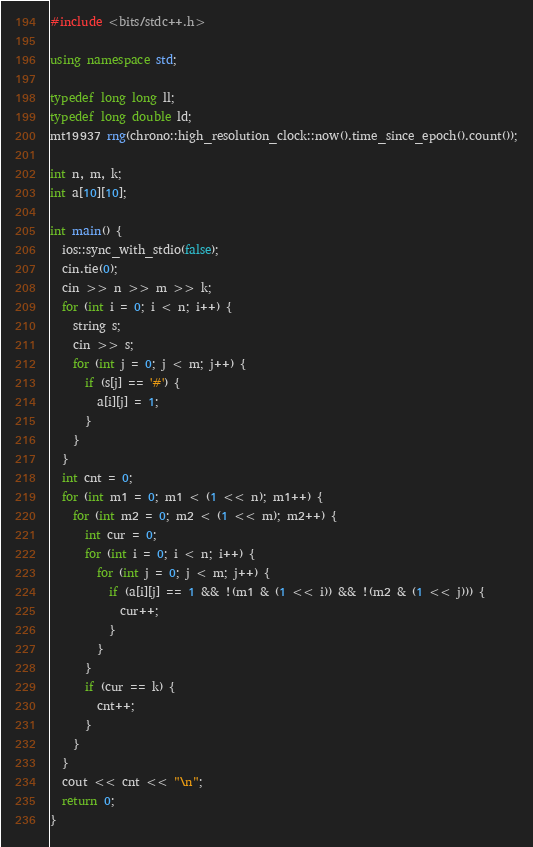<code> <loc_0><loc_0><loc_500><loc_500><_C++_>#include <bits/stdc++.h>

using namespace std;

typedef long long ll;
typedef long double ld;
mt19937 rng(chrono::high_resolution_clock::now().time_since_epoch().count());

int n, m, k;
int a[10][10];

int main() {
  ios::sync_with_stdio(false);
  cin.tie(0);
  cin >> n >> m >> k;
  for (int i = 0; i < n; i++) {
    string s;
    cin >> s;
    for (int j = 0; j < m; j++) {
      if (s[j] == '#') {
        a[i][j] = 1;
      }
    }
  }
  int cnt = 0;
  for (int m1 = 0; m1 < (1 << n); m1++) {
    for (int m2 = 0; m2 < (1 << m); m2++) {
      int cur = 0;
      for (int i = 0; i < n; i++) {
        for (int j = 0; j < m; j++) {
          if (a[i][j] == 1 && !(m1 & (1 << i)) && !(m2 & (1 << j))) {
            cur++;
          }
        }
      }
      if (cur == k) {
        cnt++;
      }
    }
  }
  cout << cnt << "\n";
  return 0;
}
</code> 